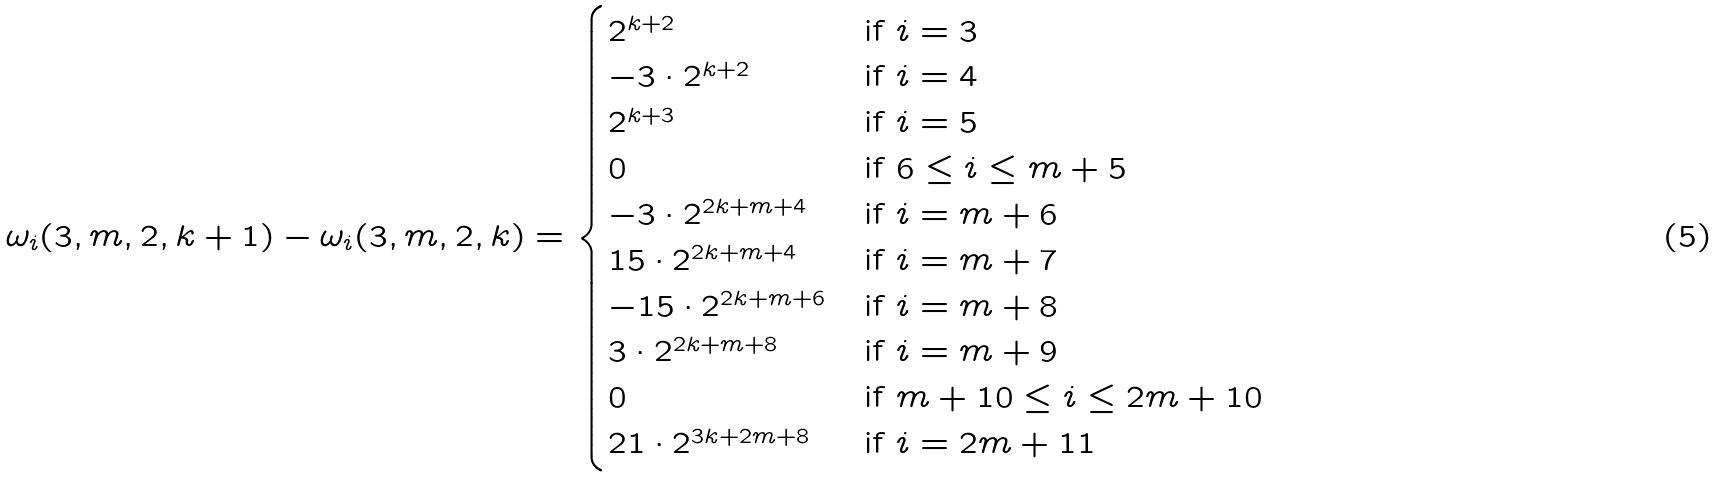Convert formula to latex. <formula><loc_0><loc_0><loc_500><loc_500>\omega _ { i } ( 3 , m , 2 , k + 1 ) - \omega _ { i } ( 3 , m , 2 , k ) = \begin{cases} 2 ^ { k + 2 } & \text {if } i = 3 \\ - 3 \cdot 2 ^ { k + 2 } & \text {if } i = 4 \\ 2 ^ { k + 3 } & \text {if } i = 5 \\ 0 & \text {if } 6 \leq i \leq m + 5 \\ - 3 \cdot 2 ^ { 2 k + m + 4 } & \text {if } i = m + 6 \\ 1 5 \cdot 2 ^ { 2 k + m + 4 } & \text {if } i = m + 7 \\ - 1 5 \cdot 2 ^ { 2 k + m + 6 } & \text {if } i = m + 8 \\ 3 \cdot 2 ^ { 2 k + m + 8 } & \text {if } i = m + 9 \\ 0 & \text {if } m + 1 0 \leq i \leq 2 m + 1 0 \\ 2 1 \cdot 2 ^ { 3 k + 2 m + 8 } & \text {if } i = 2 m + 1 1 \end{cases}</formula> 